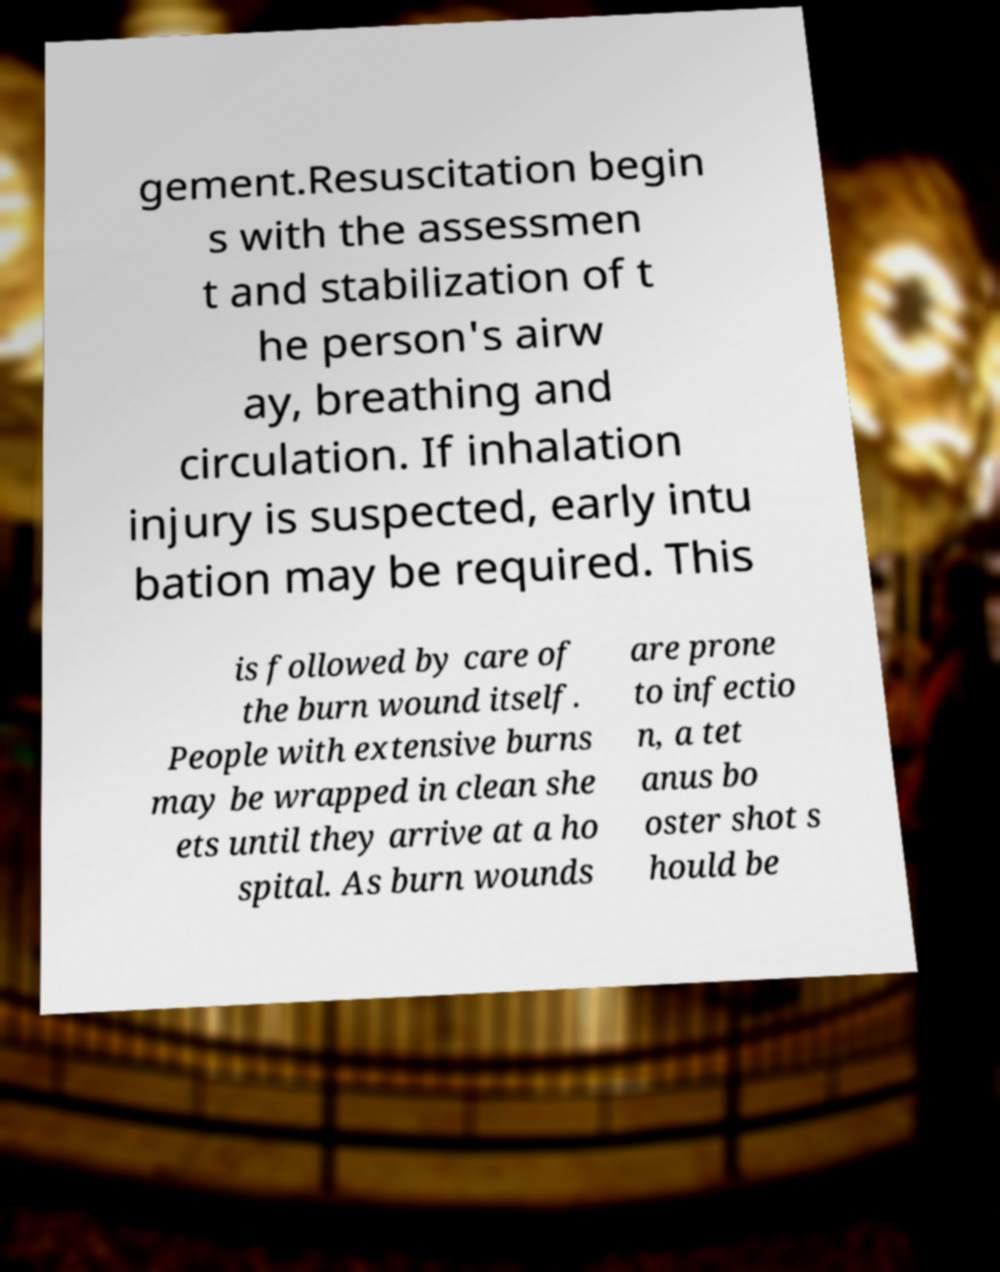Can you read and provide the text displayed in the image?This photo seems to have some interesting text. Can you extract and type it out for me? gement.Resuscitation begin s with the assessmen t and stabilization of t he person's airw ay, breathing and circulation. If inhalation injury is suspected, early intu bation may be required. This is followed by care of the burn wound itself. People with extensive burns may be wrapped in clean she ets until they arrive at a ho spital. As burn wounds are prone to infectio n, a tet anus bo oster shot s hould be 